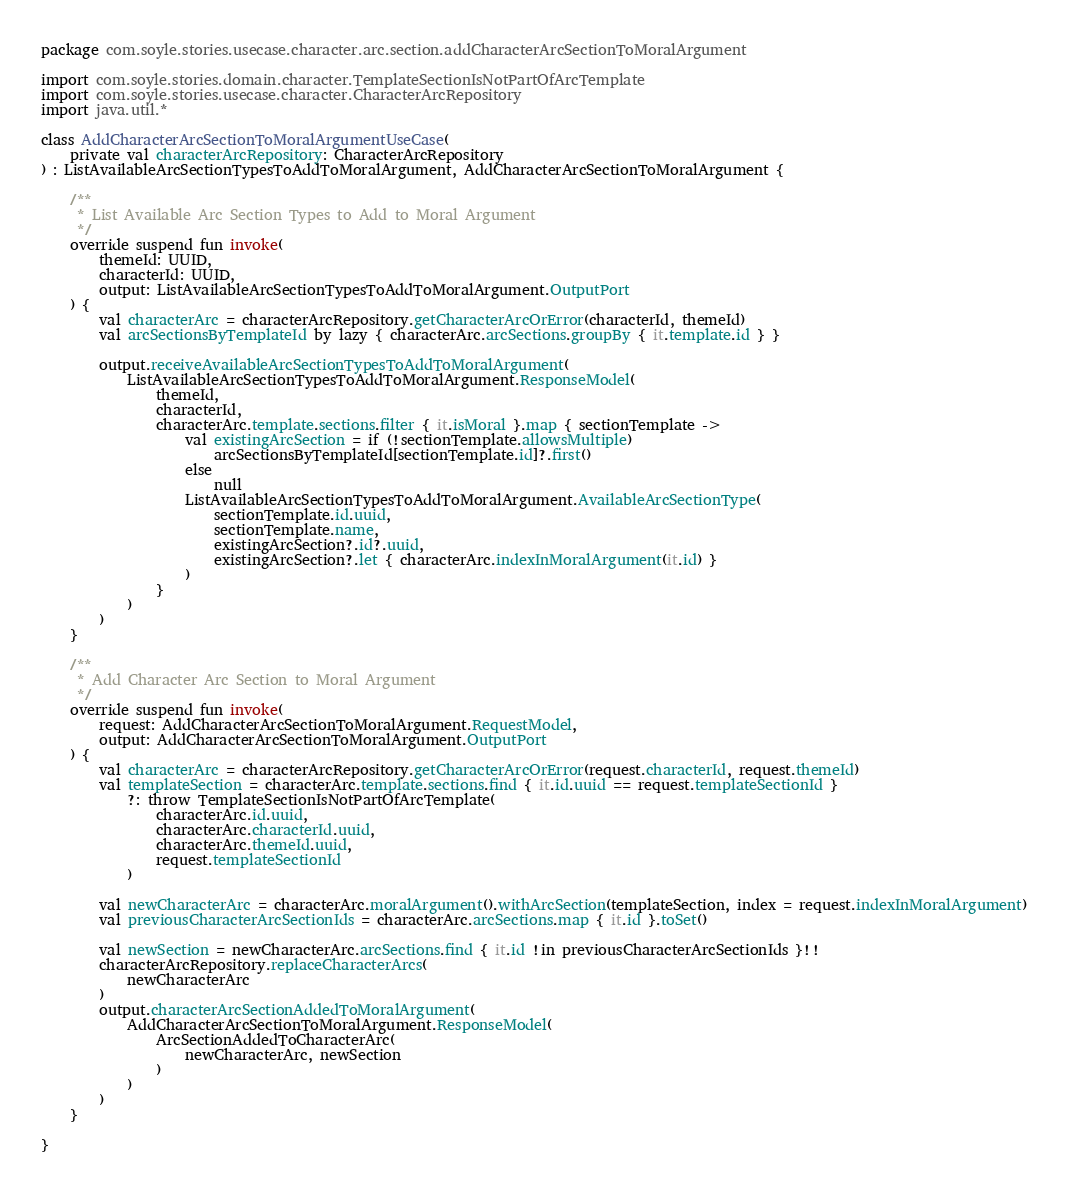<code> <loc_0><loc_0><loc_500><loc_500><_Kotlin_>package com.soyle.stories.usecase.character.arc.section.addCharacterArcSectionToMoralArgument

import com.soyle.stories.domain.character.TemplateSectionIsNotPartOfArcTemplate
import com.soyle.stories.usecase.character.CharacterArcRepository
import java.util.*

class AddCharacterArcSectionToMoralArgumentUseCase(
    private val characterArcRepository: CharacterArcRepository
) : ListAvailableArcSectionTypesToAddToMoralArgument, AddCharacterArcSectionToMoralArgument {

    /**
     * List Available Arc Section Types to Add to Moral Argument
     */
    override suspend fun invoke(
        themeId: UUID,
        characterId: UUID,
        output: ListAvailableArcSectionTypesToAddToMoralArgument.OutputPort
    ) {
        val characterArc = characterArcRepository.getCharacterArcOrError(characterId, themeId)
        val arcSectionsByTemplateId by lazy { characterArc.arcSections.groupBy { it.template.id } }

        output.receiveAvailableArcSectionTypesToAddToMoralArgument(
            ListAvailableArcSectionTypesToAddToMoralArgument.ResponseModel(
                themeId,
                characterId,
                characterArc.template.sections.filter { it.isMoral }.map { sectionTemplate ->
                    val existingArcSection = if (!sectionTemplate.allowsMultiple)
                        arcSectionsByTemplateId[sectionTemplate.id]?.first()
                    else
                        null
                    ListAvailableArcSectionTypesToAddToMoralArgument.AvailableArcSectionType(
                        sectionTemplate.id.uuid,
                        sectionTemplate.name,
                        existingArcSection?.id?.uuid,
                        existingArcSection?.let { characterArc.indexInMoralArgument(it.id) }
                    )
                }
            )
        )
    }

    /**
     * Add Character Arc Section to Moral Argument
     */
    override suspend fun invoke(
        request: AddCharacterArcSectionToMoralArgument.RequestModel,
        output: AddCharacterArcSectionToMoralArgument.OutputPort
    ) {
        val characterArc = characterArcRepository.getCharacterArcOrError(request.characterId, request.themeId)
        val templateSection = characterArc.template.sections.find { it.id.uuid == request.templateSectionId }
            ?: throw TemplateSectionIsNotPartOfArcTemplate(
                characterArc.id.uuid,
                characterArc.characterId.uuid,
                characterArc.themeId.uuid,
                request.templateSectionId
            )

        val newCharacterArc = characterArc.moralArgument().withArcSection(templateSection, index = request.indexInMoralArgument)
        val previousCharacterArcSectionIds = characterArc.arcSections.map { it.id }.toSet()

        val newSection = newCharacterArc.arcSections.find { it.id !in previousCharacterArcSectionIds }!!
        characterArcRepository.replaceCharacterArcs(
            newCharacterArc
        )
        output.characterArcSectionAddedToMoralArgument(
            AddCharacterArcSectionToMoralArgument.ResponseModel(
                ArcSectionAddedToCharacterArc(
                    newCharacterArc, newSection
                )
            )
        )
    }

}</code> 